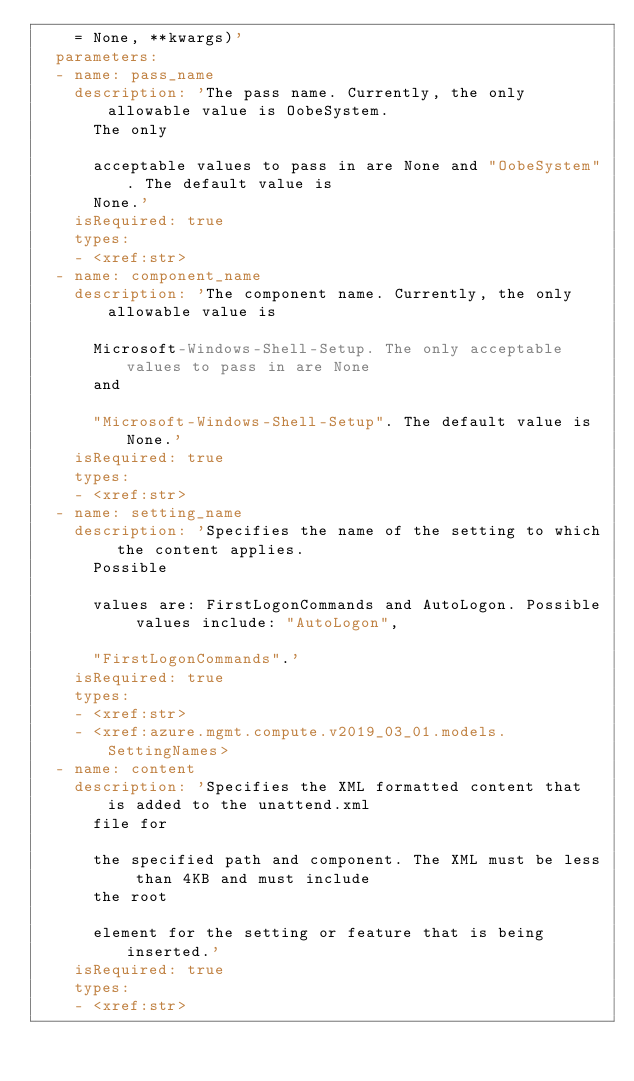Convert code to text. <code><loc_0><loc_0><loc_500><loc_500><_YAML_>    = None, **kwargs)'
  parameters:
  - name: pass_name
    description: 'The pass name. Currently, the only allowable value is OobeSystem.
      The only

      acceptable values to pass in are None and "OobeSystem". The default value is
      None.'
    isRequired: true
    types:
    - <xref:str>
  - name: component_name
    description: 'The component name. Currently, the only allowable value is

      Microsoft-Windows-Shell-Setup. The only acceptable values to pass in are None
      and

      "Microsoft-Windows-Shell-Setup". The default value is None.'
    isRequired: true
    types:
    - <xref:str>
  - name: setting_name
    description: 'Specifies the name of the setting to which the content applies.
      Possible

      values are: FirstLogonCommands and AutoLogon. Possible values include: "AutoLogon",

      "FirstLogonCommands".'
    isRequired: true
    types:
    - <xref:str>
    - <xref:azure.mgmt.compute.v2019_03_01.models.SettingNames>
  - name: content
    description: 'Specifies the XML formatted content that is added to the unattend.xml
      file for

      the specified path and component. The XML must be less than 4KB and must include
      the root

      element for the setting or feature that is being inserted.'
    isRequired: true
    types:
    - <xref:str>
</code> 